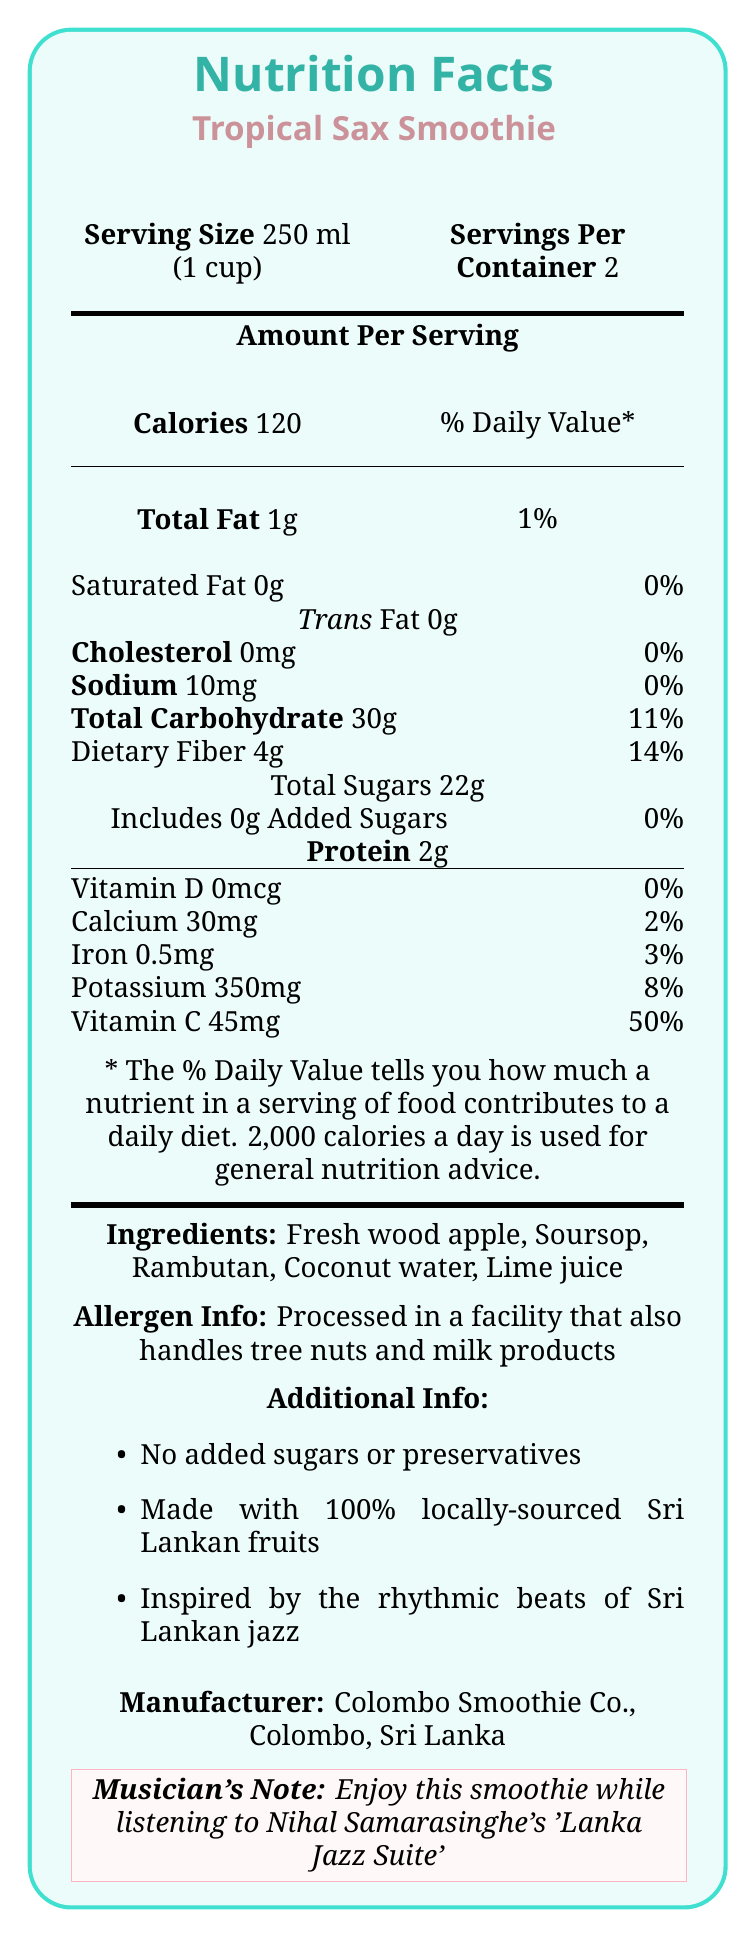What is the serving size of the Tropical Sax Smoothie? The serving size is listed as 250 ml, which is equivalent to 1 cup.
Answer: 250 ml (1 cup) How many servings are there per container of the Tropical Sax Smoothie? The document states that there are 2 servings per container.
Answer: 2 What is the total amount of calories per serving? The document specifies that the Tropical Sax Smoothie contains 120 calories per serving.
Answer: 120 calories How much total fat is there in one serving? The document lists the total fat as 1g, which is also 1% of the Daily Value.
Answer: 1g or 1% Daily Value Does the Tropical Sax Smoothie contain any added sugars? The document explicitly states that the smoothie contains 0g of added sugars.
Answer: No What is the amount of dietary fiber per serving? A. 2g B. 4g C. 6g The document reports that each serving contains 4g of dietary fiber.
Answer: B Which of the following ingredients is not listed in the Tropical Sax Smoothie? 1. Fresh wood apple 2. Soursop 3. Mango 4. Coconut water The ingredients listed are Fresh wood apple, Soursop, Rambutan, Coconut water, and Lime juice, but not Mango.
Answer: 3 Is there any cholesterol in the Tropical Sax Smoothie? The document lists the cholesterol content as 0mg.
Answer: No Does the Tropical Sax Smoothie provide any Vitamin C? The document indicates that the smoothie provides 45mg of Vitamin C, which is 50% of the Daily Value.
Answer: Yes Summarize the main information provided in the document. The document details the nutritional content and ingredients of the Tropical Sax Smoothie, made by Colombo Smoothie Co. It emphasizes local sourcing and the absence of added sugars or preservatives, and includes a musical note encouraging enjoyment of the smoothie while listening to Sri Lankan jazz.
Answer: The document provides the Nutrition Facts for the Tropical Sax Smoothie, including serving size, servings per container, calorie count, and nutrient content per serving. It includes a list of ingredients, allergen information, and additional notes about the product. The product is made with 100% locally-sourced Sri Lankan fruits, contains no added sugars or preservatives, and is inspired by Sri Lankan jazz. What is the sodium content per serving? The document states that there are 10mg of sodium per serving, which is 0% of the Daily Value.
Answer: 10mg or 0% Daily Value Which of the following benefits does the Tropical Sax Smoothie provide? A. High in protein B. High in Vitamin C C. High in saturated fat D. High in added sugars The smoothie provides a significant amount of Vitamin C (50% Daily Value) but is not high in protein, saturated fat, or added sugars.
Answer: B What is the manufacturer's location? The document states that the manufacturer, Colombo Smoothie Co., is located in Colombo, Sri Lanka.
Answer: Colombo, Sri Lanka How much potassium is in one serving? The document lists the potassium content as 350mg per serving, which is 8% of the Daily Value.
Answer: 350mg or 8% Daily Value What specific allergen information is provided? The document provides this specific allergen information indicating the potential for cross-contamination.
Answer: Processed in a facility that also handles tree nuts and milk products What is the musician's note included in the document? The document includes this note to enhance the cultural experience of the product.
Answer: Enjoy this smoothie while listening to Nihal Samarasinghe's 'Lanka Jazz Suite' What is the protein content of the Tropical Sax Smoothie? The document lists the protein content as 2g per serving.
Answer: 2g Does the Nutrition Facts label indicate the presence of preservatives? The document states there are no preservatives in the Tropical Sax Smoothie.
Answer: No What is the percentage of daily value for iron per serving? The document indicates that each serving contains 0.5mg of iron, which is 3% of the Daily Value.
Answer: 3% How much Vitamin D does each serving of the smoothie contain? The document states that the Vitamin D content is 0mcg per serving, which is 0% of the Daily Value.
Answer: 0mcg or 0% Daily Value What is the total carbohydrate content per serving, and how does this contribute to the daily value percentage? The document lists the total carbohydrate content as 30g per serving, which is 11% of the Daily Value.
Answer: 30g or 11% Daily Value How much of the tropical blue ingredient is included in the smoothie? The document does not mention any ingredient called "tropical blue," so this information cannot be determined.
Answer: Cannot be determined 